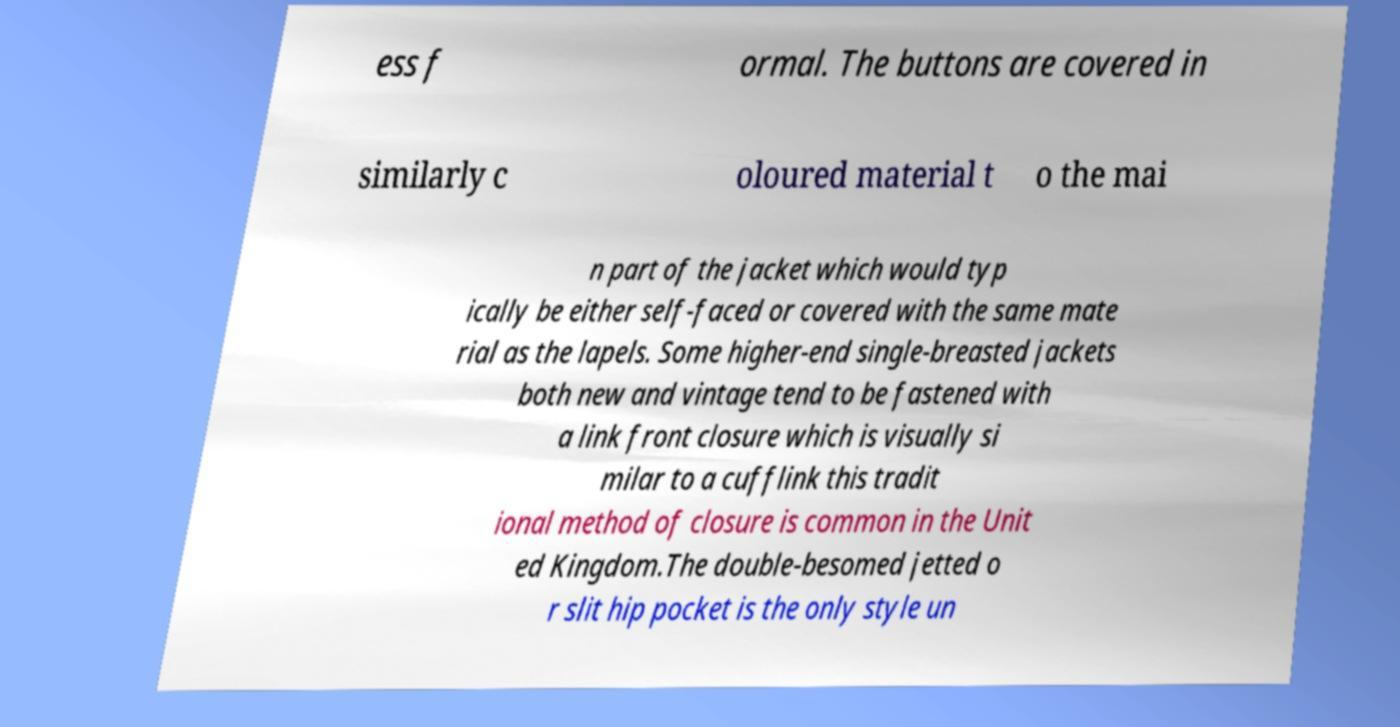Can you accurately transcribe the text from the provided image for me? ess f ormal. The buttons are covered in similarly c oloured material t o the mai n part of the jacket which would typ ically be either self-faced or covered with the same mate rial as the lapels. Some higher-end single-breasted jackets both new and vintage tend to be fastened with a link front closure which is visually si milar to a cufflink this tradit ional method of closure is common in the Unit ed Kingdom.The double-besomed jetted o r slit hip pocket is the only style un 